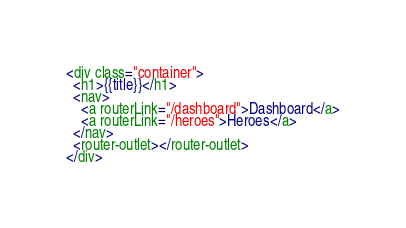Convert code to text. <code><loc_0><loc_0><loc_500><loc_500><_HTML_><div class="container">
  <h1>{{title}}</h1>
  <nav>
    <a routerLink="/dashboard">Dashboard</a>
    <a routerLink="/heroes">Heroes</a>
  </nav>
  <router-outlet></router-outlet>
</div>
</code> 